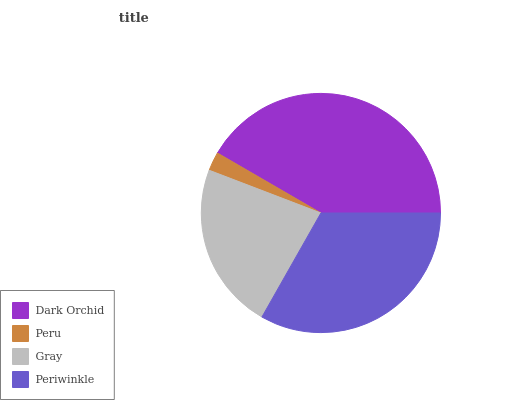Is Peru the minimum?
Answer yes or no. Yes. Is Dark Orchid the maximum?
Answer yes or no. Yes. Is Gray the minimum?
Answer yes or no. No. Is Gray the maximum?
Answer yes or no. No. Is Gray greater than Peru?
Answer yes or no. Yes. Is Peru less than Gray?
Answer yes or no. Yes. Is Peru greater than Gray?
Answer yes or no. No. Is Gray less than Peru?
Answer yes or no. No. Is Periwinkle the high median?
Answer yes or no. Yes. Is Gray the low median?
Answer yes or no. Yes. Is Dark Orchid the high median?
Answer yes or no. No. Is Periwinkle the low median?
Answer yes or no. No. 